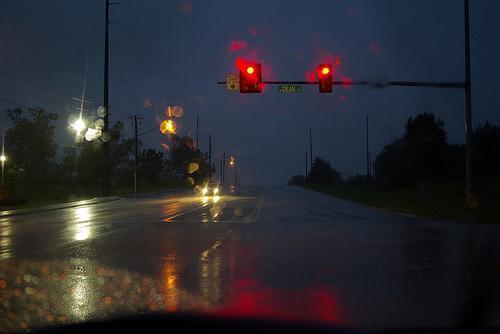How many cars on road?
Give a very brief answer. 1. 